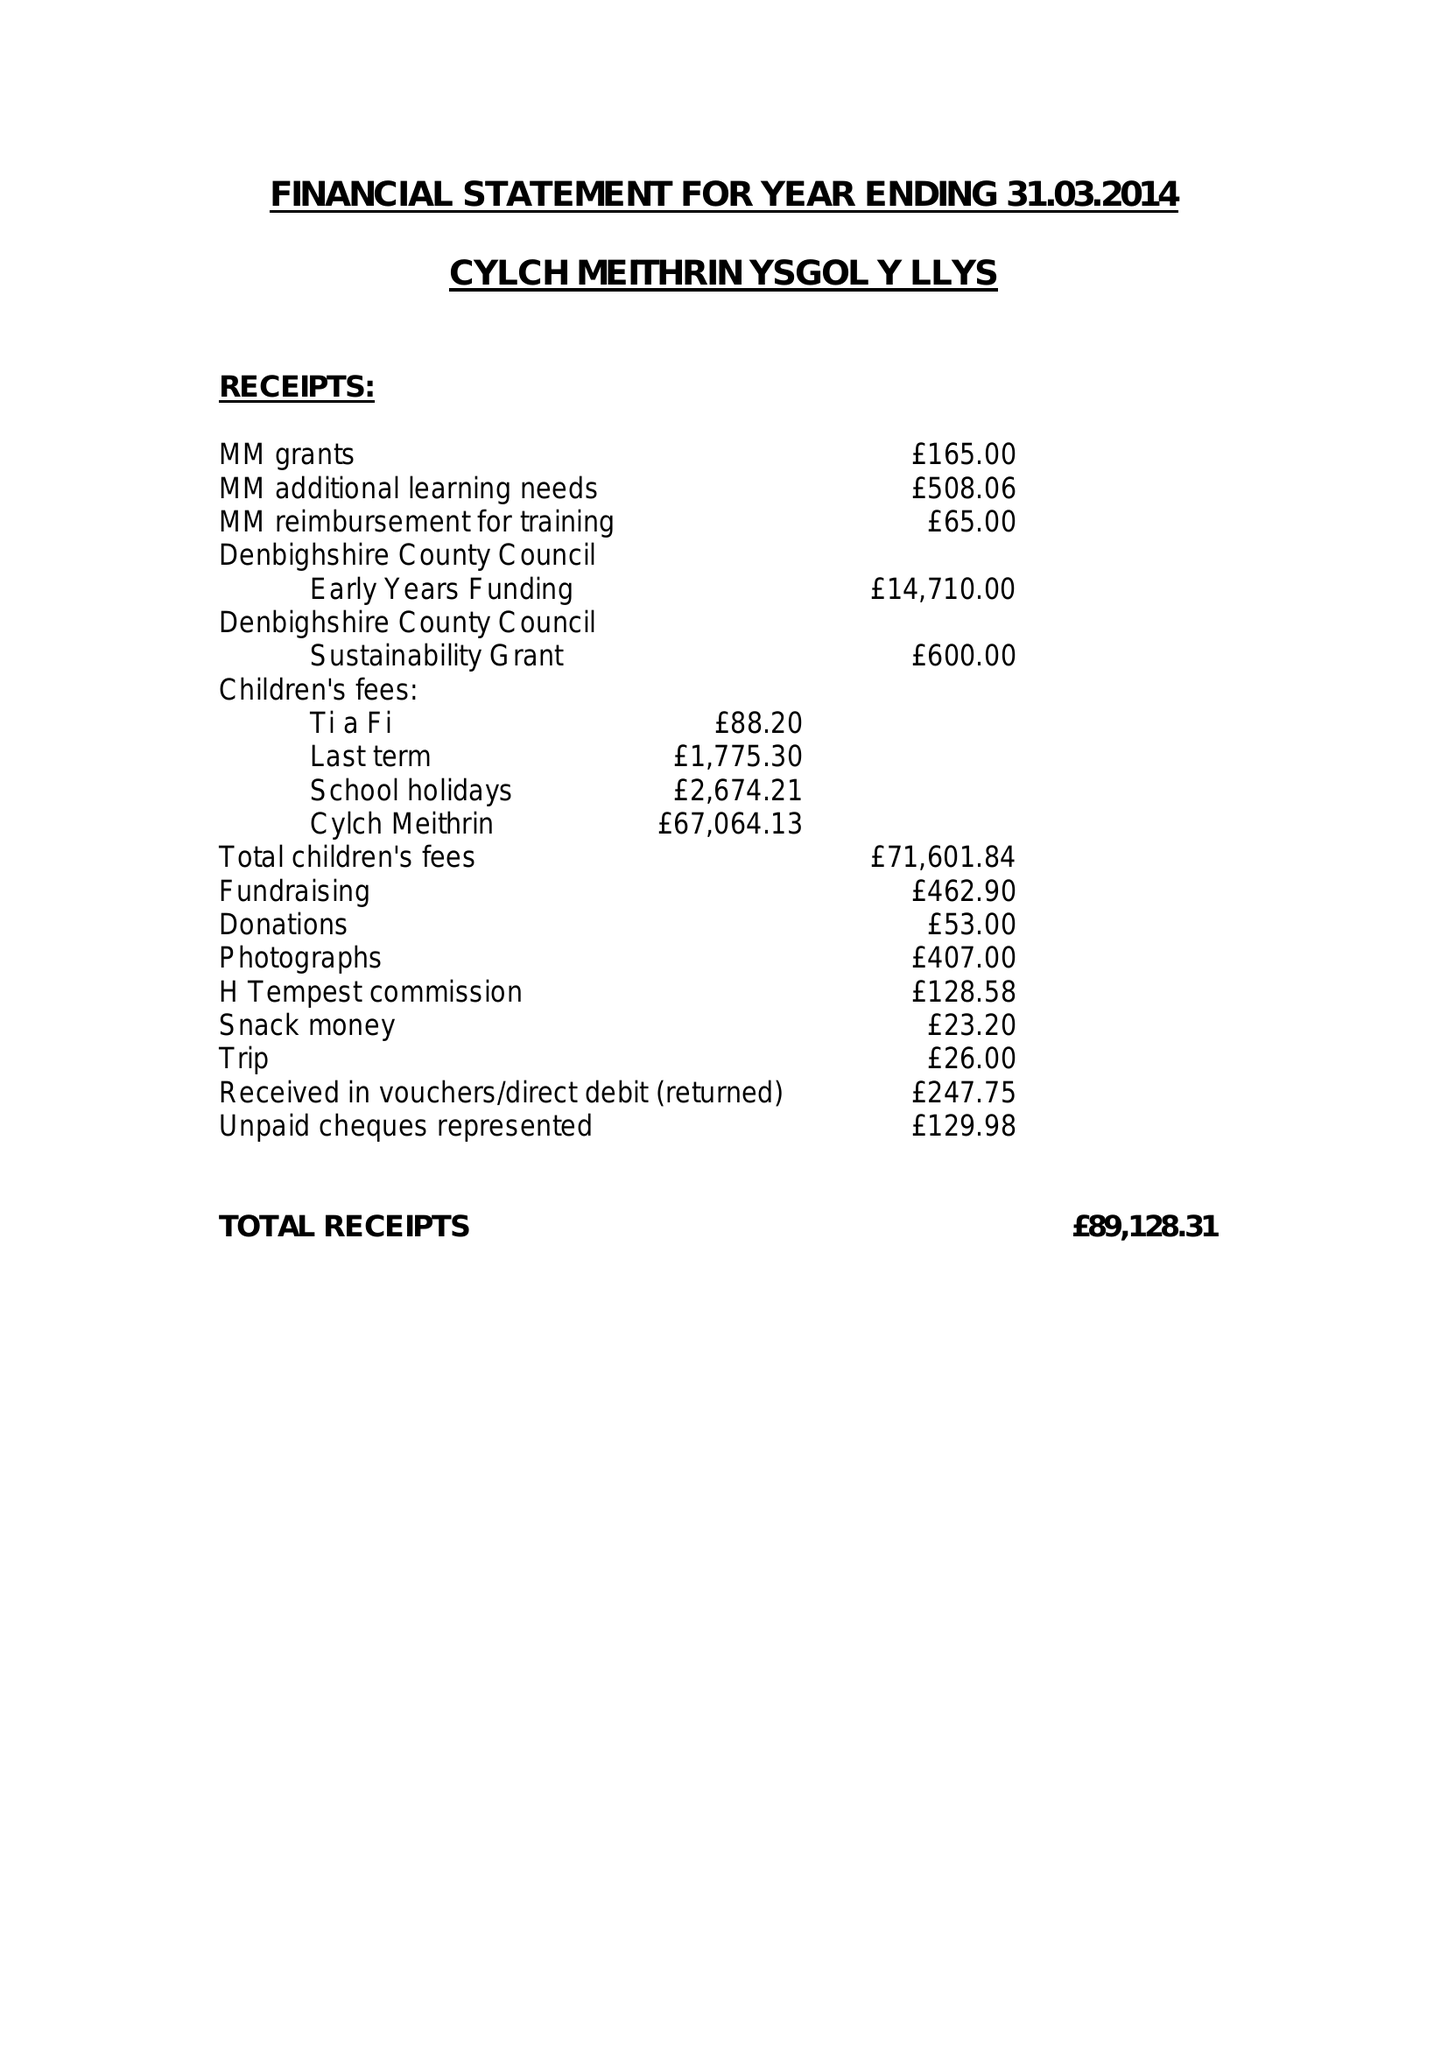What is the value for the charity_number?
Answer the question using a single word or phrase. 1063613 